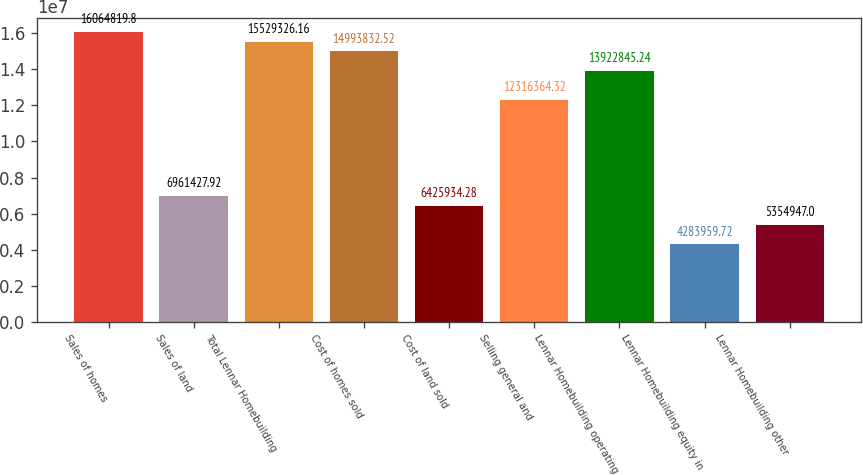<chart> <loc_0><loc_0><loc_500><loc_500><bar_chart><fcel>Sales of homes<fcel>Sales of land<fcel>Total Lennar Homebuilding<fcel>Cost of homes sold<fcel>Cost of land sold<fcel>Selling general and<fcel>Lennar Homebuilding operating<fcel>Lennar Homebuilding equity in<fcel>Lennar Homebuilding other<nl><fcel>1.60648e+07<fcel>6.96143e+06<fcel>1.55293e+07<fcel>1.49938e+07<fcel>6.42593e+06<fcel>1.23164e+07<fcel>1.39228e+07<fcel>4.28396e+06<fcel>5.35495e+06<nl></chart> 